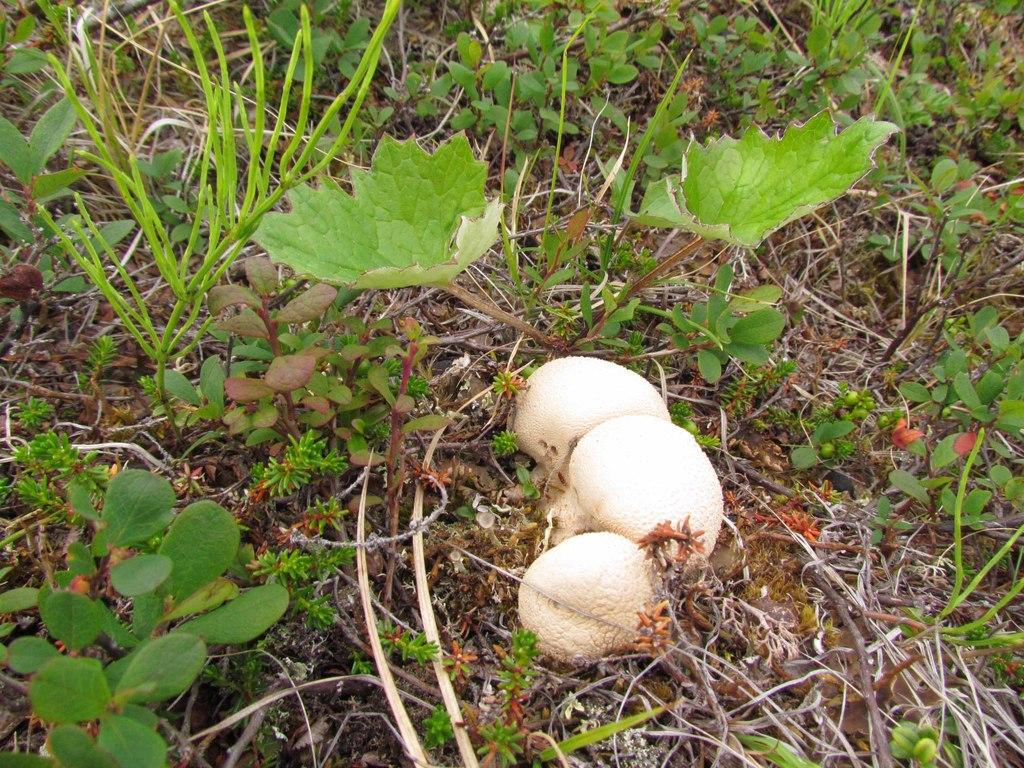What type of living organisms can be seen in the image? Plants and mushrooms are visible in the image. Where are the plants and mushrooms located? The plants and mushrooms are on the ground in the image. How does the giraffe interact with the plants in the image? There is no giraffe present in the image, so it cannot interact with the plants. 